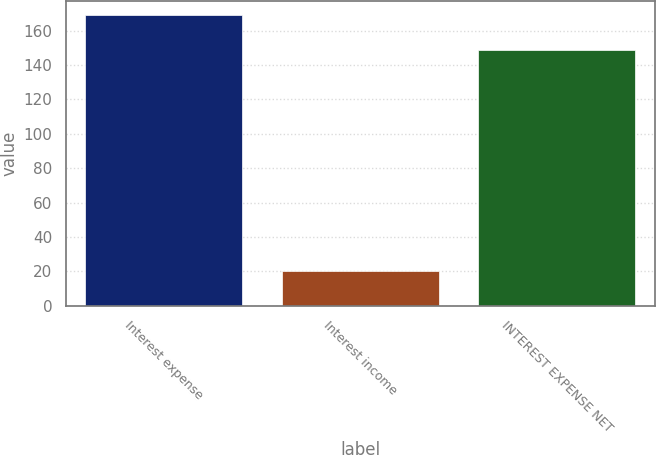Convert chart to OTSL. <chart><loc_0><loc_0><loc_500><loc_500><bar_chart><fcel>Interest expense<fcel>Interest income<fcel>INTEREST EXPENSE NET<nl><fcel>169<fcel>20<fcel>149<nl></chart> 